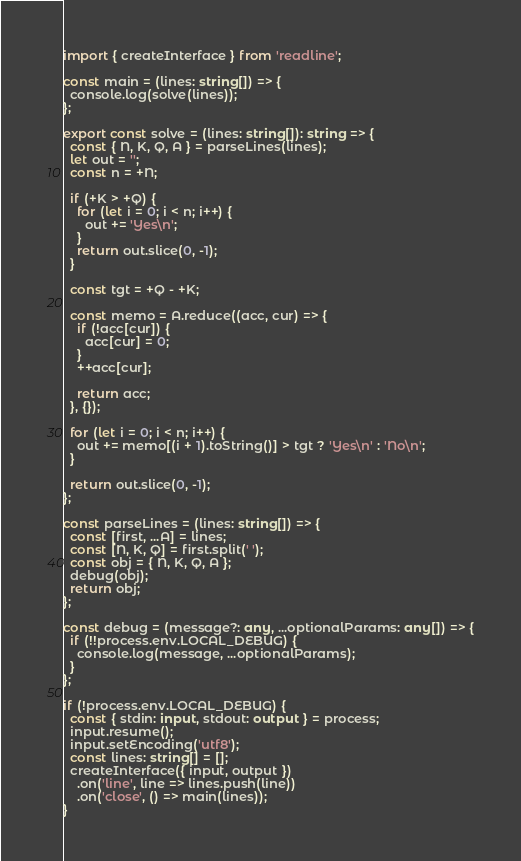<code> <loc_0><loc_0><loc_500><loc_500><_TypeScript_>import { createInterface } from 'readline';

const main = (lines: string[]) => {
  console.log(solve(lines));
};

export const solve = (lines: string[]): string => {
  const { N, K, Q, A } = parseLines(lines);
  let out = '';
  const n = +N;

  if (+K > +Q) {
    for (let i = 0; i < n; i++) {
      out += 'Yes\n';
    }
    return out.slice(0, -1);
  }

  const tgt = +Q - +K;

  const memo = A.reduce((acc, cur) => {
    if (!acc[cur]) {
      acc[cur] = 0;
    }
    ++acc[cur];

    return acc;
  }, {});

  for (let i = 0; i < n; i++) {
    out += memo[(i + 1).toString()] > tgt ? 'Yes\n' : 'No\n';
  }

  return out.slice(0, -1);
};

const parseLines = (lines: string[]) => {
  const [first, ...A] = lines;
  const [N, K, Q] = first.split(' ');
  const obj = { N, K, Q, A };
  debug(obj);
  return obj;
};

const debug = (message?: any, ...optionalParams: any[]) => {
  if (!!process.env.LOCAL_DEBUG) {
    console.log(message, ...optionalParams);
  }
};

if (!process.env.LOCAL_DEBUG) {
  const { stdin: input, stdout: output } = process;
  input.resume();
  input.setEncoding('utf8');
  const lines: string[] = [];
  createInterface({ input, output })
    .on('line', line => lines.push(line))
    .on('close', () => main(lines));
}
</code> 